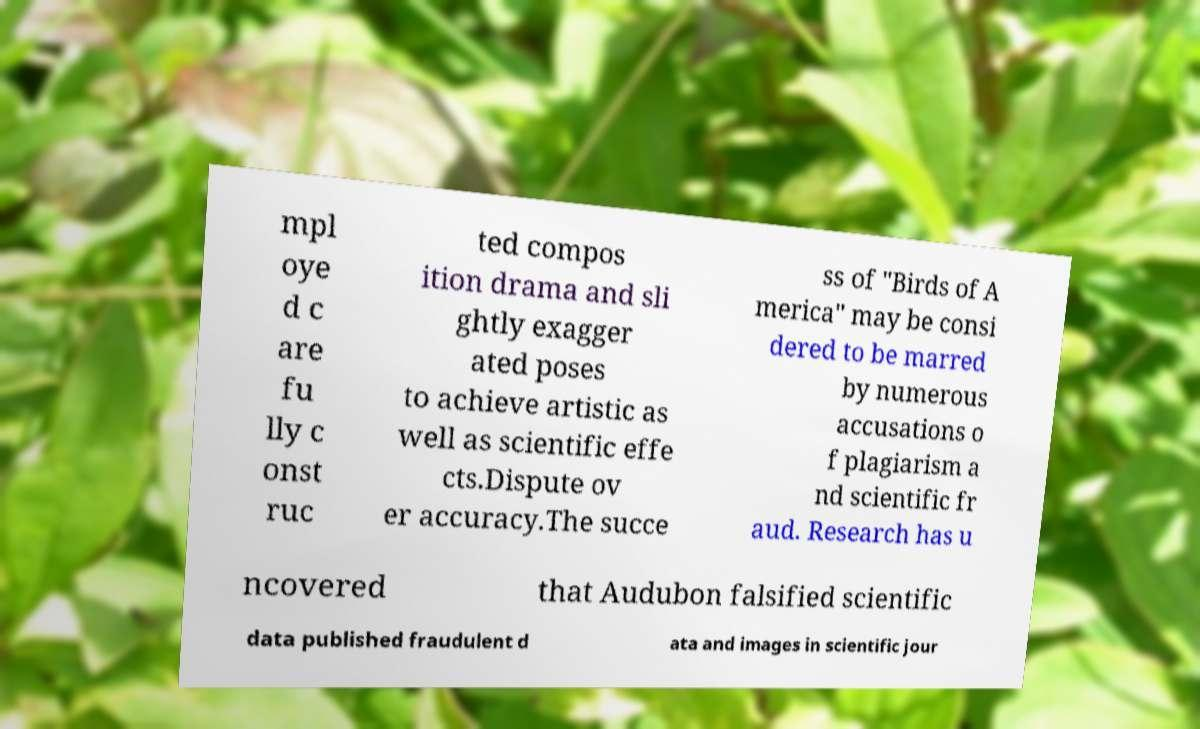Please identify and transcribe the text found in this image. mpl oye d c are fu lly c onst ruc ted compos ition drama and sli ghtly exagger ated poses to achieve artistic as well as scientific effe cts.Dispute ov er accuracy.The succe ss of "Birds of A merica" may be consi dered to be marred by numerous accusations o f plagiarism a nd scientific fr aud. Research has u ncovered that Audubon falsified scientific data published fraudulent d ata and images in scientific jour 